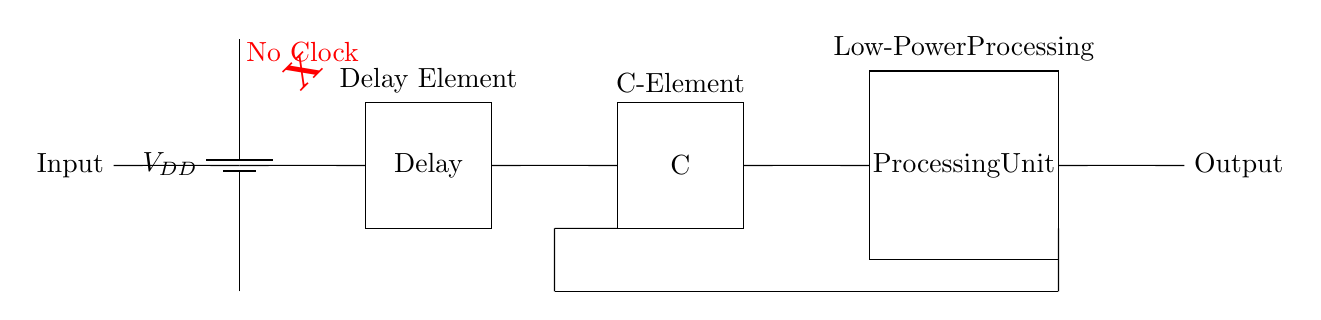what is the type of the processing unit? The processing unit is labeled as “Processing Unit” in the circuit diagram, indicating it performs computations or processes data.
Answer: Processing Unit what does the delay element do? The delay element is marked as “Delay” in the diagram, implying it introduces a time delay before the signal continues, playing a crucial role in synchronous operations within the circuit.
Answer: Delay how is the output connected to the processing unit? The output connects directly from the processing unit, indicating a straightforward flow of processed data from the processing unit to the output stage.
Answer: Short what component indicates that the circuit is asynchronous? The red "No Clock" notation on the diagram signifies the absence of a clock signal, a key characteristic that defines the circuit as asynchronous.
Answer: No Clock what is the function of the C-element? The C-element described in the circuit as “C” is used for synchronization, allowing the circuit to wait until all inputs are stable before providing the output, thus preventing race conditions.
Answer: Synchronization how many key components are there in this circuit? The circuit contains four main components: a power supply, a delay element, a C-element, and a processing unit, indicating the basic structure needed for function execution.
Answer: Four what does the feedback loop achieve in this circuit? The feedback loop connects the output back to the C-element, facilitating stability by ensuring that the output remains consistent with the inputs, effectively regulating the behavior of the circuit.
Answer: Stability 